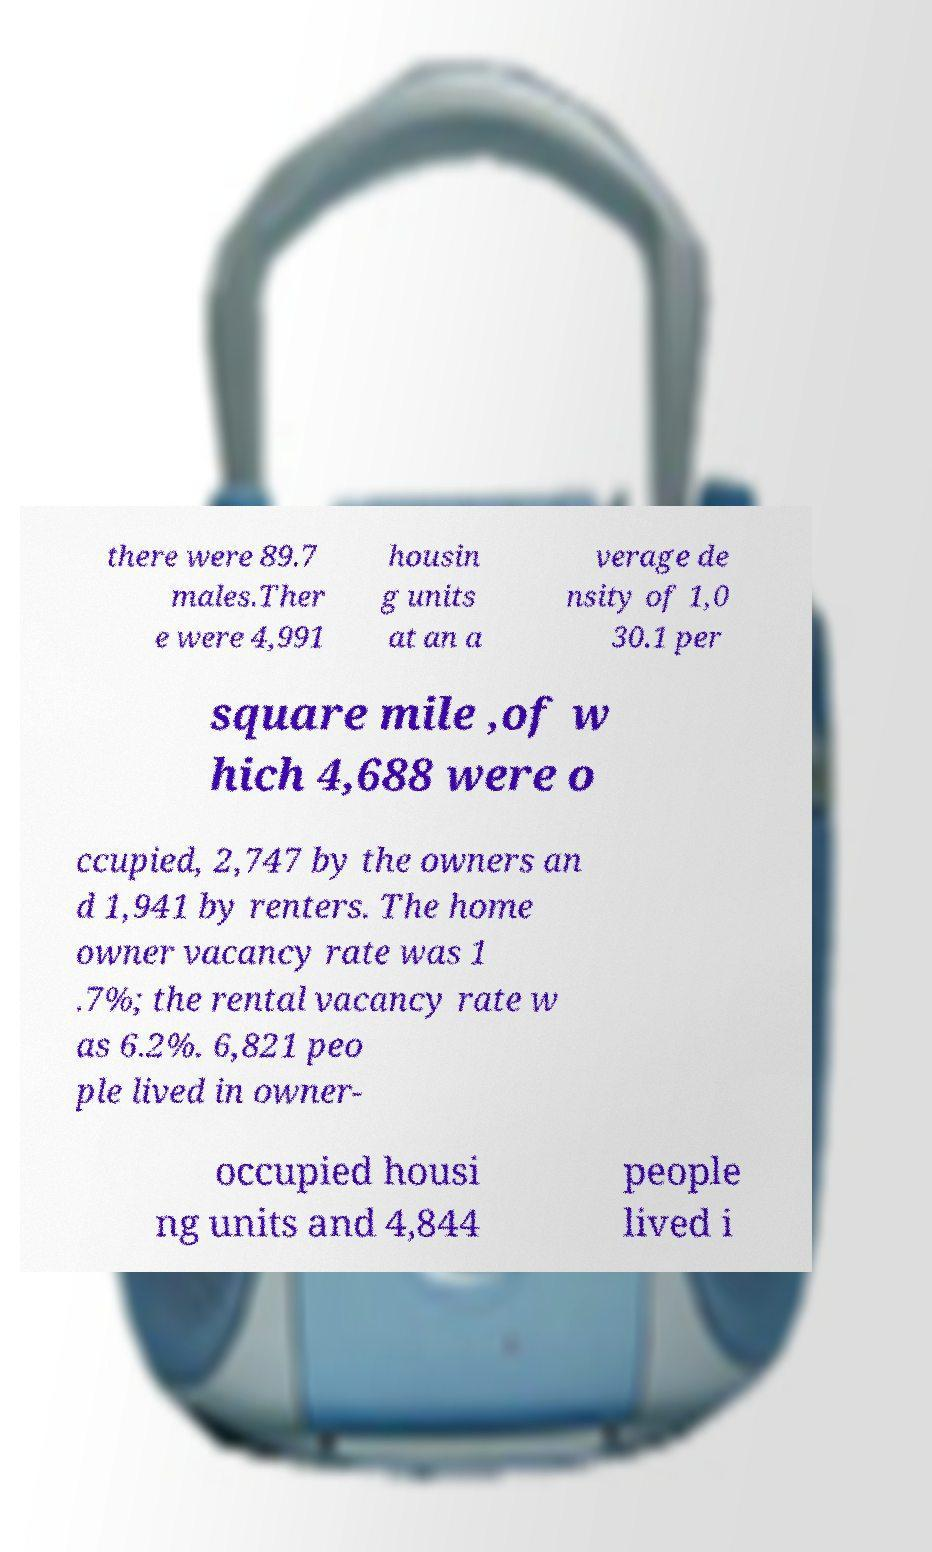Could you assist in decoding the text presented in this image and type it out clearly? there were 89.7 males.Ther e were 4,991 housin g units at an a verage de nsity of 1,0 30.1 per square mile ,of w hich 4,688 were o ccupied, 2,747 by the owners an d 1,941 by renters. The home owner vacancy rate was 1 .7%; the rental vacancy rate w as 6.2%. 6,821 peo ple lived in owner- occupied housi ng units and 4,844 people lived i 